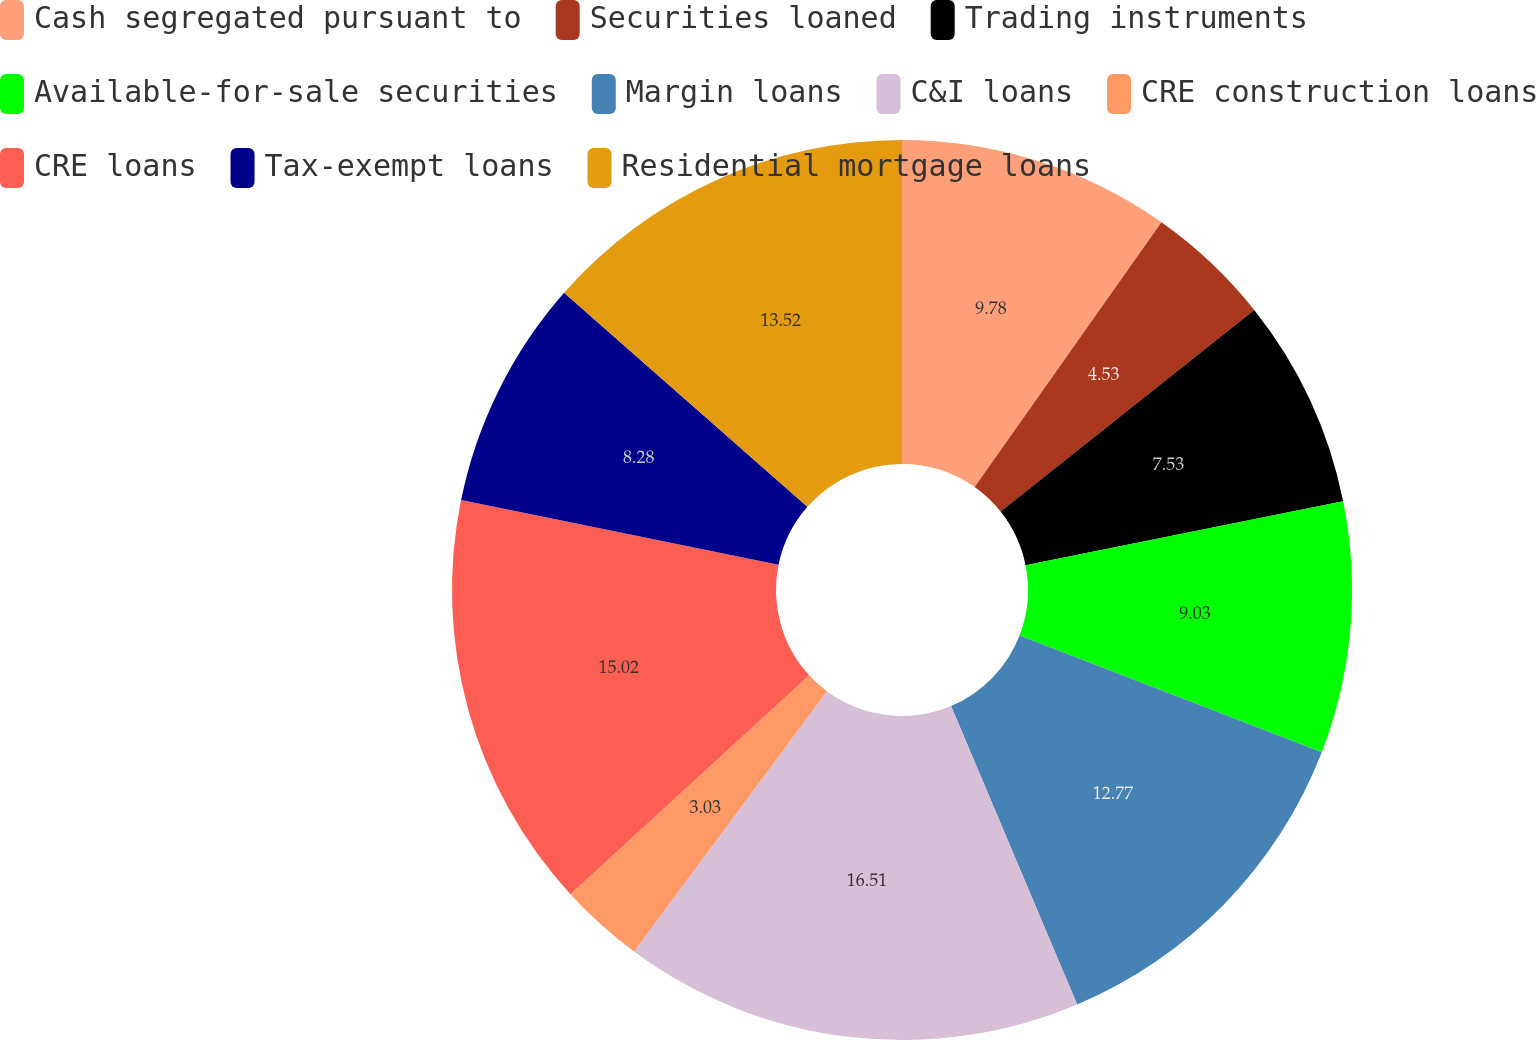<chart> <loc_0><loc_0><loc_500><loc_500><pie_chart><fcel>Cash segregated pursuant to<fcel>Securities loaned<fcel>Trading instruments<fcel>Available-for-sale securities<fcel>Margin loans<fcel>C&I loans<fcel>CRE construction loans<fcel>CRE loans<fcel>Tax-exempt loans<fcel>Residential mortgage loans<nl><fcel>9.78%<fcel>4.53%<fcel>7.53%<fcel>9.03%<fcel>12.77%<fcel>16.52%<fcel>3.03%<fcel>15.02%<fcel>8.28%<fcel>13.52%<nl></chart> 